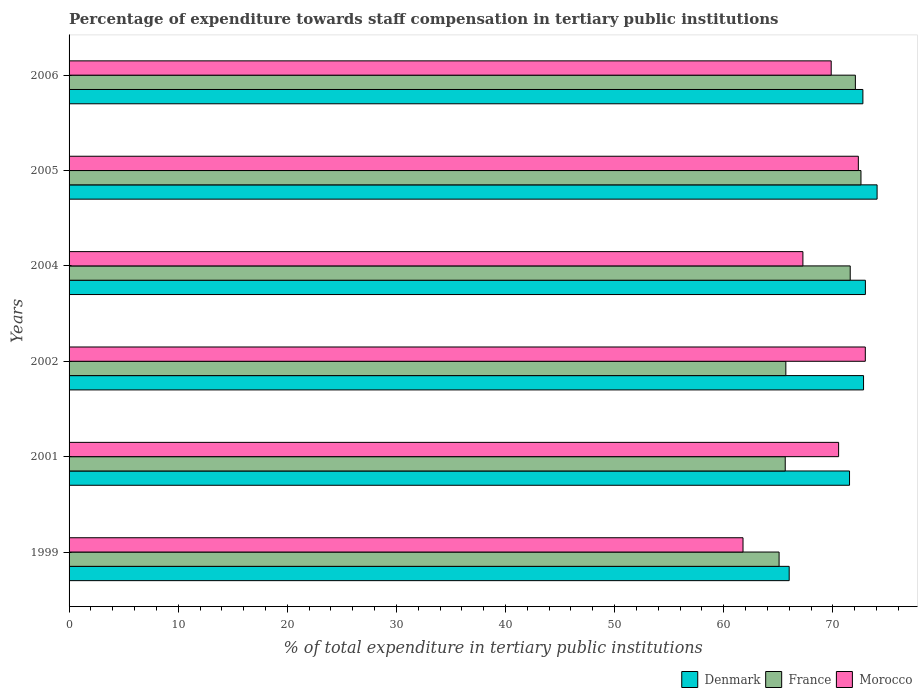How many different coloured bars are there?
Keep it short and to the point. 3. Are the number of bars per tick equal to the number of legend labels?
Provide a short and direct response. Yes. Are the number of bars on each tick of the Y-axis equal?
Your answer should be compact. Yes. What is the label of the 2nd group of bars from the top?
Offer a very short reply. 2005. In how many cases, is the number of bars for a given year not equal to the number of legend labels?
Offer a very short reply. 0. What is the percentage of expenditure towards staff compensation in Morocco in 2005?
Ensure brevity in your answer.  72.34. Across all years, what is the maximum percentage of expenditure towards staff compensation in Morocco?
Provide a short and direct response. 72.98. Across all years, what is the minimum percentage of expenditure towards staff compensation in France?
Provide a succinct answer. 65.08. What is the total percentage of expenditure towards staff compensation in Denmark in the graph?
Offer a very short reply. 430.15. What is the difference between the percentage of expenditure towards staff compensation in Morocco in 1999 and that in 2006?
Your response must be concise. -8.08. What is the difference between the percentage of expenditure towards staff compensation in Denmark in 1999 and the percentage of expenditure towards staff compensation in Morocco in 2002?
Provide a short and direct response. -6.98. What is the average percentage of expenditure towards staff compensation in Morocco per year?
Your response must be concise. 69.12. In the year 2006, what is the difference between the percentage of expenditure towards staff compensation in France and percentage of expenditure towards staff compensation in Morocco?
Make the answer very short. 2.22. In how many years, is the percentage of expenditure towards staff compensation in Denmark greater than 26 %?
Offer a terse response. 6. What is the ratio of the percentage of expenditure towards staff compensation in France in 2001 to that in 2002?
Keep it short and to the point. 1. What is the difference between the highest and the second highest percentage of expenditure towards staff compensation in Denmark?
Provide a succinct answer. 1.07. What is the difference between the highest and the lowest percentage of expenditure towards staff compensation in Morocco?
Provide a short and direct response. 11.21. In how many years, is the percentage of expenditure towards staff compensation in Morocco greater than the average percentage of expenditure towards staff compensation in Morocco taken over all years?
Provide a short and direct response. 4. What does the 1st bar from the top in 2001 represents?
Your answer should be compact. Morocco. What does the 3rd bar from the bottom in 2005 represents?
Your response must be concise. Morocco. Is it the case that in every year, the sum of the percentage of expenditure towards staff compensation in Denmark and percentage of expenditure towards staff compensation in France is greater than the percentage of expenditure towards staff compensation in Morocco?
Provide a short and direct response. Yes. Are the values on the major ticks of X-axis written in scientific E-notation?
Your answer should be very brief. No. How are the legend labels stacked?
Offer a terse response. Horizontal. What is the title of the graph?
Your answer should be compact. Percentage of expenditure towards staff compensation in tertiary public institutions. Does "New Caledonia" appear as one of the legend labels in the graph?
Provide a short and direct response. No. What is the label or title of the X-axis?
Give a very brief answer. % of total expenditure in tertiary public institutions. What is the label or title of the Y-axis?
Your answer should be very brief. Years. What is the % of total expenditure in tertiary public institutions of Denmark in 1999?
Keep it short and to the point. 66. What is the % of total expenditure in tertiary public institutions of France in 1999?
Make the answer very short. 65.08. What is the % of total expenditure in tertiary public institutions in Morocco in 1999?
Ensure brevity in your answer.  61.77. What is the % of total expenditure in tertiary public institutions in Denmark in 2001?
Ensure brevity in your answer.  71.53. What is the % of total expenditure in tertiary public institutions of France in 2001?
Provide a short and direct response. 65.64. What is the % of total expenditure in tertiary public institutions in Morocco in 2001?
Offer a terse response. 70.53. What is the % of total expenditure in tertiary public institutions in Denmark in 2002?
Give a very brief answer. 72.82. What is the % of total expenditure in tertiary public institutions of France in 2002?
Provide a short and direct response. 65.69. What is the % of total expenditure in tertiary public institutions of Morocco in 2002?
Your answer should be compact. 72.98. What is the % of total expenditure in tertiary public institutions of Denmark in 2004?
Provide a succinct answer. 72.99. What is the % of total expenditure in tertiary public institutions of France in 2004?
Offer a terse response. 71.6. What is the % of total expenditure in tertiary public institutions of Morocco in 2004?
Make the answer very short. 67.26. What is the % of total expenditure in tertiary public institutions of Denmark in 2005?
Offer a terse response. 74.06. What is the % of total expenditure in tertiary public institutions in France in 2005?
Your response must be concise. 72.58. What is the % of total expenditure in tertiary public institutions of Morocco in 2005?
Make the answer very short. 72.34. What is the % of total expenditure in tertiary public institutions in Denmark in 2006?
Provide a succinct answer. 72.76. What is the % of total expenditure in tertiary public institutions in France in 2006?
Make the answer very short. 72.07. What is the % of total expenditure in tertiary public institutions in Morocco in 2006?
Make the answer very short. 69.85. Across all years, what is the maximum % of total expenditure in tertiary public institutions of Denmark?
Provide a succinct answer. 74.06. Across all years, what is the maximum % of total expenditure in tertiary public institutions in France?
Provide a short and direct response. 72.58. Across all years, what is the maximum % of total expenditure in tertiary public institutions in Morocco?
Keep it short and to the point. 72.98. Across all years, what is the minimum % of total expenditure in tertiary public institutions in Denmark?
Provide a short and direct response. 66. Across all years, what is the minimum % of total expenditure in tertiary public institutions in France?
Your answer should be compact. 65.08. Across all years, what is the minimum % of total expenditure in tertiary public institutions of Morocco?
Offer a terse response. 61.77. What is the total % of total expenditure in tertiary public institutions in Denmark in the graph?
Offer a very short reply. 430.15. What is the total % of total expenditure in tertiary public institutions in France in the graph?
Make the answer very short. 412.65. What is the total % of total expenditure in tertiary public institutions of Morocco in the graph?
Offer a very short reply. 414.73. What is the difference between the % of total expenditure in tertiary public institutions in Denmark in 1999 and that in 2001?
Offer a terse response. -5.53. What is the difference between the % of total expenditure in tertiary public institutions of France in 1999 and that in 2001?
Your response must be concise. -0.56. What is the difference between the % of total expenditure in tertiary public institutions of Morocco in 1999 and that in 2001?
Give a very brief answer. -8.76. What is the difference between the % of total expenditure in tertiary public institutions in Denmark in 1999 and that in 2002?
Your answer should be compact. -6.82. What is the difference between the % of total expenditure in tertiary public institutions in France in 1999 and that in 2002?
Provide a succinct answer. -0.62. What is the difference between the % of total expenditure in tertiary public institutions of Morocco in 1999 and that in 2002?
Give a very brief answer. -11.21. What is the difference between the % of total expenditure in tertiary public institutions of Denmark in 1999 and that in 2004?
Give a very brief answer. -6.98. What is the difference between the % of total expenditure in tertiary public institutions in France in 1999 and that in 2004?
Provide a succinct answer. -6.52. What is the difference between the % of total expenditure in tertiary public institutions in Morocco in 1999 and that in 2004?
Provide a short and direct response. -5.49. What is the difference between the % of total expenditure in tertiary public institutions of Denmark in 1999 and that in 2005?
Keep it short and to the point. -8.06. What is the difference between the % of total expenditure in tertiary public institutions of France in 1999 and that in 2005?
Your answer should be compact. -7.5. What is the difference between the % of total expenditure in tertiary public institutions of Morocco in 1999 and that in 2005?
Your answer should be compact. -10.57. What is the difference between the % of total expenditure in tertiary public institutions of Denmark in 1999 and that in 2006?
Your response must be concise. -6.75. What is the difference between the % of total expenditure in tertiary public institutions in France in 1999 and that in 2006?
Offer a very short reply. -6.99. What is the difference between the % of total expenditure in tertiary public institutions in Morocco in 1999 and that in 2006?
Make the answer very short. -8.08. What is the difference between the % of total expenditure in tertiary public institutions of Denmark in 2001 and that in 2002?
Offer a very short reply. -1.28. What is the difference between the % of total expenditure in tertiary public institutions of France in 2001 and that in 2002?
Make the answer very short. -0.06. What is the difference between the % of total expenditure in tertiary public institutions of Morocco in 2001 and that in 2002?
Make the answer very short. -2.45. What is the difference between the % of total expenditure in tertiary public institutions of Denmark in 2001 and that in 2004?
Your answer should be very brief. -1.45. What is the difference between the % of total expenditure in tertiary public institutions in France in 2001 and that in 2004?
Give a very brief answer. -5.96. What is the difference between the % of total expenditure in tertiary public institutions of Morocco in 2001 and that in 2004?
Offer a terse response. 3.27. What is the difference between the % of total expenditure in tertiary public institutions in Denmark in 2001 and that in 2005?
Ensure brevity in your answer.  -2.53. What is the difference between the % of total expenditure in tertiary public institutions of France in 2001 and that in 2005?
Keep it short and to the point. -6.94. What is the difference between the % of total expenditure in tertiary public institutions of Morocco in 2001 and that in 2005?
Provide a succinct answer. -1.81. What is the difference between the % of total expenditure in tertiary public institutions of Denmark in 2001 and that in 2006?
Your answer should be compact. -1.22. What is the difference between the % of total expenditure in tertiary public institutions in France in 2001 and that in 2006?
Your answer should be compact. -6.43. What is the difference between the % of total expenditure in tertiary public institutions in Morocco in 2001 and that in 2006?
Give a very brief answer. 0.68. What is the difference between the % of total expenditure in tertiary public institutions in Denmark in 2002 and that in 2004?
Your answer should be compact. -0.17. What is the difference between the % of total expenditure in tertiary public institutions of France in 2002 and that in 2004?
Keep it short and to the point. -5.9. What is the difference between the % of total expenditure in tertiary public institutions in Morocco in 2002 and that in 2004?
Offer a very short reply. 5.72. What is the difference between the % of total expenditure in tertiary public institutions in Denmark in 2002 and that in 2005?
Ensure brevity in your answer.  -1.24. What is the difference between the % of total expenditure in tertiary public institutions of France in 2002 and that in 2005?
Make the answer very short. -6.89. What is the difference between the % of total expenditure in tertiary public institutions of Morocco in 2002 and that in 2005?
Provide a succinct answer. 0.64. What is the difference between the % of total expenditure in tertiary public institutions of Denmark in 2002 and that in 2006?
Offer a very short reply. 0.06. What is the difference between the % of total expenditure in tertiary public institutions of France in 2002 and that in 2006?
Offer a terse response. -6.37. What is the difference between the % of total expenditure in tertiary public institutions of Morocco in 2002 and that in 2006?
Your answer should be compact. 3.13. What is the difference between the % of total expenditure in tertiary public institutions of Denmark in 2004 and that in 2005?
Provide a short and direct response. -1.07. What is the difference between the % of total expenditure in tertiary public institutions in France in 2004 and that in 2005?
Offer a terse response. -0.99. What is the difference between the % of total expenditure in tertiary public institutions of Morocco in 2004 and that in 2005?
Your answer should be very brief. -5.08. What is the difference between the % of total expenditure in tertiary public institutions of Denmark in 2004 and that in 2006?
Your answer should be compact. 0.23. What is the difference between the % of total expenditure in tertiary public institutions in France in 2004 and that in 2006?
Make the answer very short. -0.47. What is the difference between the % of total expenditure in tertiary public institutions in Morocco in 2004 and that in 2006?
Your response must be concise. -2.59. What is the difference between the % of total expenditure in tertiary public institutions in Denmark in 2005 and that in 2006?
Your response must be concise. 1.3. What is the difference between the % of total expenditure in tertiary public institutions in France in 2005 and that in 2006?
Ensure brevity in your answer.  0.51. What is the difference between the % of total expenditure in tertiary public institutions in Morocco in 2005 and that in 2006?
Your answer should be compact. 2.49. What is the difference between the % of total expenditure in tertiary public institutions of Denmark in 1999 and the % of total expenditure in tertiary public institutions of France in 2001?
Provide a short and direct response. 0.36. What is the difference between the % of total expenditure in tertiary public institutions of Denmark in 1999 and the % of total expenditure in tertiary public institutions of Morocco in 2001?
Ensure brevity in your answer.  -4.53. What is the difference between the % of total expenditure in tertiary public institutions of France in 1999 and the % of total expenditure in tertiary public institutions of Morocco in 2001?
Your answer should be very brief. -5.45. What is the difference between the % of total expenditure in tertiary public institutions in Denmark in 1999 and the % of total expenditure in tertiary public institutions in France in 2002?
Your answer should be compact. 0.31. What is the difference between the % of total expenditure in tertiary public institutions of Denmark in 1999 and the % of total expenditure in tertiary public institutions of Morocco in 2002?
Give a very brief answer. -6.98. What is the difference between the % of total expenditure in tertiary public institutions in France in 1999 and the % of total expenditure in tertiary public institutions in Morocco in 2002?
Provide a short and direct response. -7.9. What is the difference between the % of total expenditure in tertiary public institutions of Denmark in 1999 and the % of total expenditure in tertiary public institutions of France in 2004?
Offer a very short reply. -5.59. What is the difference between the % of total expenditure in tertiary public institutions of Denmark in 1999 and the % of total expenditure in tertiary public institutions of Morocco in 2004?
Offer a very short reply. -1.26. What is the difference between the % of total expenditure in tertiary public institutions in France in 1999 and the % of total expenditure in tertiary public institutions in Morocco in 2004?
Provide a short and direct response. -2.18. What is the difference between the % of total expenditure in tertiary public institutions of Denmark in 1999 and the % of total expenditure in tertiary public institutions of France in 2005?
Keep it short and to the point. -6.58. What is the difference between the % of total expenditure in tertiary public institutions in Denmark in 1999 and the % of total expenditure in tertiary public institutions in Morocco in 2005?
Provide a succinct answer. -6.34. What is the difference between the % of total expenditure in tertiary public institutions of France in 1999 and the % of total expenditure in tertiary public institutions of Morocco in 2005?
Provide a short and direct response. -7.26. What is the difference between the % of total expenditure in tertiary public institutions in Denmark in 1999 and the % of total expenditure in tertiary public institutions in France in 2006?
Your answer should be compact. -6.07. What is the difference between the % of total expenditure in tertiary public institutions in Denmark in 1999 and the % of total expenditure in tertiary public institutions in Morocco in 2006?
Keep it short and to the point. -3.85. What is the difference between the % of total expenditure in tertiary public institutions of France in 1999 and the % of total expenditure in tertiary public institutions of Morocco in 2006?
Provide a short and direct response. -4.78. What is the difference between the % of total expenditure in tertiary public institutions of Denmark in 2001 and the % of total expenditure in tertiary public institutions of France in 2002?
Provide a short and direct response. 5.84. What is the difference between the % of total expenditure in tertiary public institutions of Denmark in 2001 and the % of total expenditure in tertiary public institutions of Morocco in 2002?
Offer a terse response. -1.45. What is the difference between the % of total expenditure in tertiary public institutions of France in 2001 and the % of total expenditure in tertiary public institutions of Morocco in 2002?
Offer a terse response. -7.34. What is the difference between the % of total expenditure in tertiary public institutions in Denmark in 2001 and the % of total expenditure in tertiary public institutions in France in 2004?
Offer a terse response. -0.06. What is the difference between the % of total expenditure in tertiary public institutions in Denmark in 2001 and the % of total expenditure in tertiary public institutions in Morocco in 2004?
Provide a short and direct response. 4.27. What is the difference between the % of total expenditure in tertiary public institutions in France in 2001 and the % of total expenditure in tertiary public institutions in Morocco in 2004?
Make the answer very short. -1.62. What is the difference between the % of total expenditure in tertiary public institutions of Denmark in 2001 and the % of total expenditure in tertiary public institutions of France in 2005?
Your answer should be compact. -1.05. What is the difference between the % of total expenditure in tertiary public institutions of Denmark in 2001 and the % of total expenditure in tertiary public institutions of Morocco in 2005?
Your answer should be compact. -0.81. What is the difference between the % of total expenditure in tertiary public institutions in France in 2001 and the % of total expenditure in tertiary public institutions in Morocco in 2005?
Make the answer very short. -6.7. What is the difference between the % of total expenditure in tertiary public institutions of Denmark in 2001 and the % of total expenditure in tertiary public institutions of France in 2006?
Offer a terse response. -0.54. What is the difference between the % of total expenditure in tertiary public institutions of Denmark in 2001 and the % of total expenditure in tertiary public institutions of Morocco in 2006?
Ensure brevity in your answer.  1.68. What is the difference between the % of total expenditure in tertiary public institutions in France in 2001 and the % of total expenditure in tertiary public institutions in Morocco in 2006?
Your answer should be compact. -4.21. What is the difference between the % of total expenditure in tertiary public institutions of Denmark in 2002 and the % of total expenditure in tertiary public institutions of France in 2004?
Keep it short and to the point. 1.22. What is the difference between the % of total expenditure in tertiary public institutions of Denmark in 2002 and the % of total expenditure in tertiary public institutions of Morocco in 2004?
Offer a terse response. 5.56. What is the difference between the % of total expenditure in tertiary public institutions in France in 2002 and the % of total expenditure in tertiary public institutions in Morocco in 2004?
Your answer should be compact. -1.56. What is the difference between the % of total expenditure in tertiary public institutions of Denmark in 2002 and the % of total expenditure in tertiary public institutions of France in 2005?
Provide a short and direct response. 0.24. What is the difference between the % of total expenditure in tertiary public institutions of Denmark in 2002 and the % of total expenditure in tertiary public institutions of Morocco in 2005?
Offer a very short reply. 0.48. What is the difference between the % of total expenditure in tertiary public institutions in France in 2002 and the % of total expenditure in tertiary public institutions in Morocco in 2005?
Your answer should be compact. -6.64. What is the difference between the % of total expenditure in tertiary public institutions in Denmark in 2002 and the % of total expenditure in tertiary public institutions in France in 2006?
Your response must be concise. 0.75. What is the difference between the % of total expenditure in tertiary public institutions of Denmark in 2002 and the % of total expenditure in tertiary public institutions of Morocco in 2006?
Ensure brevity in your answer.  2.96. What is the difference between the % of total expenditure in tertiary public institutions of France in 2002 and the % of total expenditure in tertiary public institutions of Morocco in 2006?
Offer a terse response. -4.16. What is the difference between the % of total expenditure in tertiary public institutions in Denmark in 2004 and the % of total expenditure in tertiary public institutions in France in 2005?
Provide a short and direct response. 0.4. What is the difference between the % of total expenditure in tertiary public institutions in Denmark in 2004 and the % of total expenditure in tertiary public institutions in Morocco in 2005?
Ensure brevity in your answer.  0.65. What is the difference between the % of total expenditure in tertiary public institutions of France in 2004 and the % of total expenditure in tertiary public institutions of Morocco in 2005?
Provide a short and direct response. -0.74. What is the difference between the % of total expenditure in tertiary public institutions of Denmark in 2004 and the % of total expenditure in tertiary public institutions of France in 2006?
Keep it short and to the point. 0.92. What is the difference between the % of total expenditure in tertiary public institutions of Denmark in 2004 and the % of total expenditure in tertiary public institutions of Morocco in 2006?
Make the answer very short. 3.13. What is the difference between the % of total expenditure in tertiary public institutions of France in 2004 and the % of total expenditure in tertiary public institutions of Morocco in 2006?
Your response must be concise. 1.74. What is the difference between the % of total expenditure in tertiary public institutions of Denmark in 2005 and the % of total expenditure in tertiary public institutions of France in 2006?
Give a very brief answer. 1.99. What is the difference between the % of total expenditure in tertiary public institutions of Denmark in 2005 and the % of total expenditure in tertiary public institutions of Morocco in 2006?
Give a very brief answer. 4.21. What is the difference between the % of total expenditure in tertiary public institutions in France in 2005 and the % of total expenditure in tertiary public institutions in Morocco in 2006?
Provide a short and direct response. 2.73. What is the average % of total expenditure in tertiary public institutions of Denmark per year?
Make the answer very short. 71.69. What is the average % of total expenditure in tertiary public institutions in France per year?
Keep it short and to the point. 68.78. What is the average % of total expenditure in tertiary public institutions of Morocco per year?
Keep it short and to the point. 69.12. In the year 1999, what is the difference between the % of total expenditure in tertiary public institutions of Denmark and % of total expenditure in tertiary public institutions of France?
Ensure brevity in your answer.  0.92. In the year 1999, what is the difference between the % of total expenditure in tertiary public institutions in Denmark and % of total expenditure in tertiary public institutions in Morocco?
Offer a terse response. 4.23. In the year 1999, what is the difference between the % of total expenditure in tertiary public institutions of France and % of total expenditure in tertiary public institutions of Morocco?
Offer a terse response. 3.31. In the year 2001, what is the difference between the % of total expenditure in tertiary public institutions in Denmark and % of total expenditure in tertiary public institutions in France?
Ensure brevity in your answer.  5.89. In the year 2001, what is the difference between the % of total expenditure in tertiary public institutions in France and % of total expenditure in tertiary public institutions in Morocco?
Make the answer very short. -4.89. In the year 2002, what is the difference between the % of total expenditure in tertiary public institutions in Denmark and % of total expenditure in tertiary public institutions in France?
Your answer should be compact. 7.12. In the year 2002, what is the difference between the % of total expenditure in tertiary public institutions of Denmark and % of total expenditure in tertiary public institutions of Morocco?
Give a very brief answer. -0.16. In the year 2002, what is the difference between the % of total expenditure in tertiary public institutions in France and % of total expenditure in tertiary public institutions in Morocco?
Your response must be concise. -7.28. In the year 2004, what is the difference between the % of total expenditure in tertiary public institutions of Denmark and % of total expenditure in tertiary public institutions of France?
Ensure brevity in your answer.  1.39. In the year 2004, what is the difference between the % of total expenditure in tertiary public institutions of Denmark and % of total expenditure in tertiary public institutions of Morocco?
Provide a succinct answer. 5.73. In the year 2004, what is the difference between the % of total expenditure in tertiary public institutions of France and % of total expenditure in tertiary public institutions of Morocco?
Ensure brevity in your answer.  4.34. In the year 2005, what is the difference between the % of total expenditure in tertiary public institutions of Denmark and % of total expenditure in tertiary public institutions of France?
Offer a very short reply. 1.48. In the year 2005, what is the difference between the % of total expenditure in tertiary public institutions of Denmark and % of total expenditure in tertiary public institutions of Morocco?
Make the answer very short. 1.72. In the year 2005, what is the difference between the % of total expenditure in tertiary public institutions in France and % of total expenditure in tertiary public institutions in Morocco?
Provide a succinct answer. 0.24. In the year 2006, what is the difference between the % of total expenditure in tertiary public institutions in Denmark and % of total expenditure in tertiary public institutions in France?
Your answer should be compact. 0.69. In the year 2006, what is the difference between the % of total expenditure in tertiary public institutions in Denmark and % of total expenditure in tertiary public institutions in Morocco?
Provide a short and direct response. 2.9. In the year 2006, what is the difference between the % of total expenditure in tertiary public institutions of France and % of total expenditure in tertiary public institutions of Morocco?
Your answer should be compact. 2.22. What is the ratio of the % of total expenditure in tertiary public institutions in Denmark in 1999 to that in 2001?
Your answer should be very brief. 0.92. What is the ratio of the % of total expenditure in tertiary public institutions in Morocco in 1999 to that in 2001?
Your response must be concise. 0.88. What is the ratio of the % of total expenditure in tertiary public institutions of Denmark in 1999 to that in 2002?
Give a very brief answer. 0.91. What is the ratio of the % of total expenditure in tertiary public institutions in France in 1999 to that in 2002?
Provide a succinct answer. 0.99. What is the ratio of the % of total expenditure in tertiary public institutions in Morocco in 1999 to that in 2002?
Offer a very short reply. 0.85. What is the ratio of the % of total expenditure in tertiary public institutions in Denmark in 1999 to that in 2004?
Offer a terse response. 0.9. What is the ratio of the % of total expenditure in tertiary public institutions of France in 1999 to that in 2004?
Offer a very short reply. 0.91. What is the ratio of the % of total expenditure in tertiary public institutions in Morocco in 1999 to that in 2004?
Provide a succinct answer. 0.92. What is the ratio of the % of total expenditure in tertiary public institutions of Denmark in 1999 to that in 2005?
Provide a succinct answer. 0.89. What is the ratio of the % of total expenditure in tertiary public institutions in France in 1999 to that in 2005?
Give a very brief answer. 0.9. What is the ratio of the % of total expenditure in tertiary public institutions in Morocco in 1999 to that in 2005?
Offer a terse response. 0.85. What is the ratio of the % of total expenditure in tertiary public institutions of Denmark in 1999 to that in 2006?
Your answer should be compact. 0.91. What is the ratio of the % of total expenditure in tertiary public institutions in France in 1999 to that in 2006?
Your answer should be compact. 0.9. What is the ratio of the % of total expenditure in tertiary public institutions in Morocco in 1999 to that in 2006?
Give a very brief answer. 0.88. What is the ratio of the % of total expenditure in tertiary public institutions in Denmark in 2001 to that in 2002?
Make the answer very short. 0.98. What is the ratio of the % of total expenditure in tertiary public institutions in Morocco in 2001 to that in 2002?
Your response must be concise. 0.97. What is the ratio of the % of total expenditure in tertiary public institutions of Denmark in 2001 to that in 2004?
Offer a terse response. 0.98. What is the ratio of the % of total expenditure in tertiary public institutions in France in 2001 to that in 2004?
Make the answer very short. 0.92. What is the ratio of the % of total expenditure in tertiary public institutions in Morocco in 2001 to that in 2004?
Your answer should be very brief. 1.05. What is the ratio of the % of total expenditure in tertiary public institutions in Denmark in 2001 to that in 2005?
Ensure brevity in your answer.  0.97. What is the ratio of the % of total expenditure in tertiary public institutions of France in 2001 to that in 2005?
Offer a terse response. 0.9. What is the ratio of the % of total expenditure in tertiary public institutions of Morocco in 2001 to that in 2005?
Provide a short and direct response. 0.97. What is the ratio of the % of total expenditure in tertiary public institutions in Denmark in 2001 to that in 2006?
Your response must be concise. 0.98. What is the ratio of the % of total expenditure in tertiary public institutions in France in 2001 to that in 2006?
Make the answer very short. 0.91. What is the ratio of the % of total expenditure in tertiary public institutions in Morocco in 2001 to that in 2006?
Ensure brevity in your answer.  1.01. What is the ratio of the % of total expenditure in tertiary public institutions in Denmark in 2002 to that in 2004?
Make the answer very short. 1. What is the ratio of the % of total expenditure in tertiary public institutions in France in 2002 to that in 2004?
Ensure brevity in your answer.  0.92. What is the ratio of the % of total expenditure in tertiary public institutions in Morocco in 2002 to that in 2004?
Make the answer very short. 1.08. What is the ratio of the % of total expenditure in tertiary public institutions in Denmark in 2002 to that in 2005?
Give a very brief answer. 0.98. What is the ratio of the % of total expenditure in tertiary public institutions of France in 2002 to that in 2005?
Ensure brevity in your answer.  0.91. What is the ratio of the % of total expenditure in tertiary public institutions in Morocco in 2002 to that in 2005?
Keep it short and to the point. 1.01. What is the ratio of the % of total expenditure in tertiary public institutions of Denmark in 2002 to that in 2006?
Give a very brief answer. 1. What is the ratio of the % of total expenditure in tertiary public institutions of France in 2002 to that in 2006?
Your answer should be very brief. 0.91. What is the ratio of the % of total expenditure in tertiary public institutions of Morocco in 2002 to that in 2006?
Ensure brevity in your answer.  1.04. What is the ratio of the % of total expenditure in tertiary public institutions in Denmark in 2004 to that in 2005?
Provide a short and direct response. 0.99. What is the ratio of the % of total expenditure in tertiary public institutions in France in 2004 to that in 2005?
Offer a terse response. 0.99. What is the ratio of the % of total expenditure in tertiary public institutions of Morocco in 2004 to that in 2005?
Give a very brief answer. 0.93. What is the ratio of the % of total expenditure in tertiary public institutions of Denmark in 2004 to that in 2006?
Your answer should be compact. 1. What is the ratio of the % of total expenditure in tertiary public institutions of Morocco in 2004 to that in 2006?
Offer a very short reply. 0.96. What is the ratio of the % of total expenditure in tertiary public institutions of Denmark in 2005 to that in 2006?
Give a very brief answer. 1.02. What is the ratio of the % of total expenditure in tertiary public institutions of France in 2005 to that in 2006?
Ensure brevity in your answer.  1.01. What is the ratio of the % of total expenditure in tertiary public institutions in Morocco in 2005 to that in 2006?
Your response must be concise. 1.04. What is the difference between the highest and the second highest % of total expenditure in tertiary public institutions of Denmark?
Ensure brevity in your answer.  1.07. What is the difference between the highest and the second highest % of total expenditure in tertiary public institutions of France?
Make the answer very short. 0.51. What is the difference between the highest and the second highest % of total expenditure in tertiary public institutions in Morocco?
Make the answer very short. 0.64. What is the difference between the highest and the lowest % of total expenditure in tertiary public institutions of Denmark?
Your answer should be very brief. 8.06. What is the difference between the highest and the lowest % of total expenditure in tertiary public institutions in France?
Ensure brevity in your answer.  7.5. What is the difference between the highest and the lowest % of total expenditure in tertiary public institutions of Morocco?
Give a very brief answer. 11.21. 